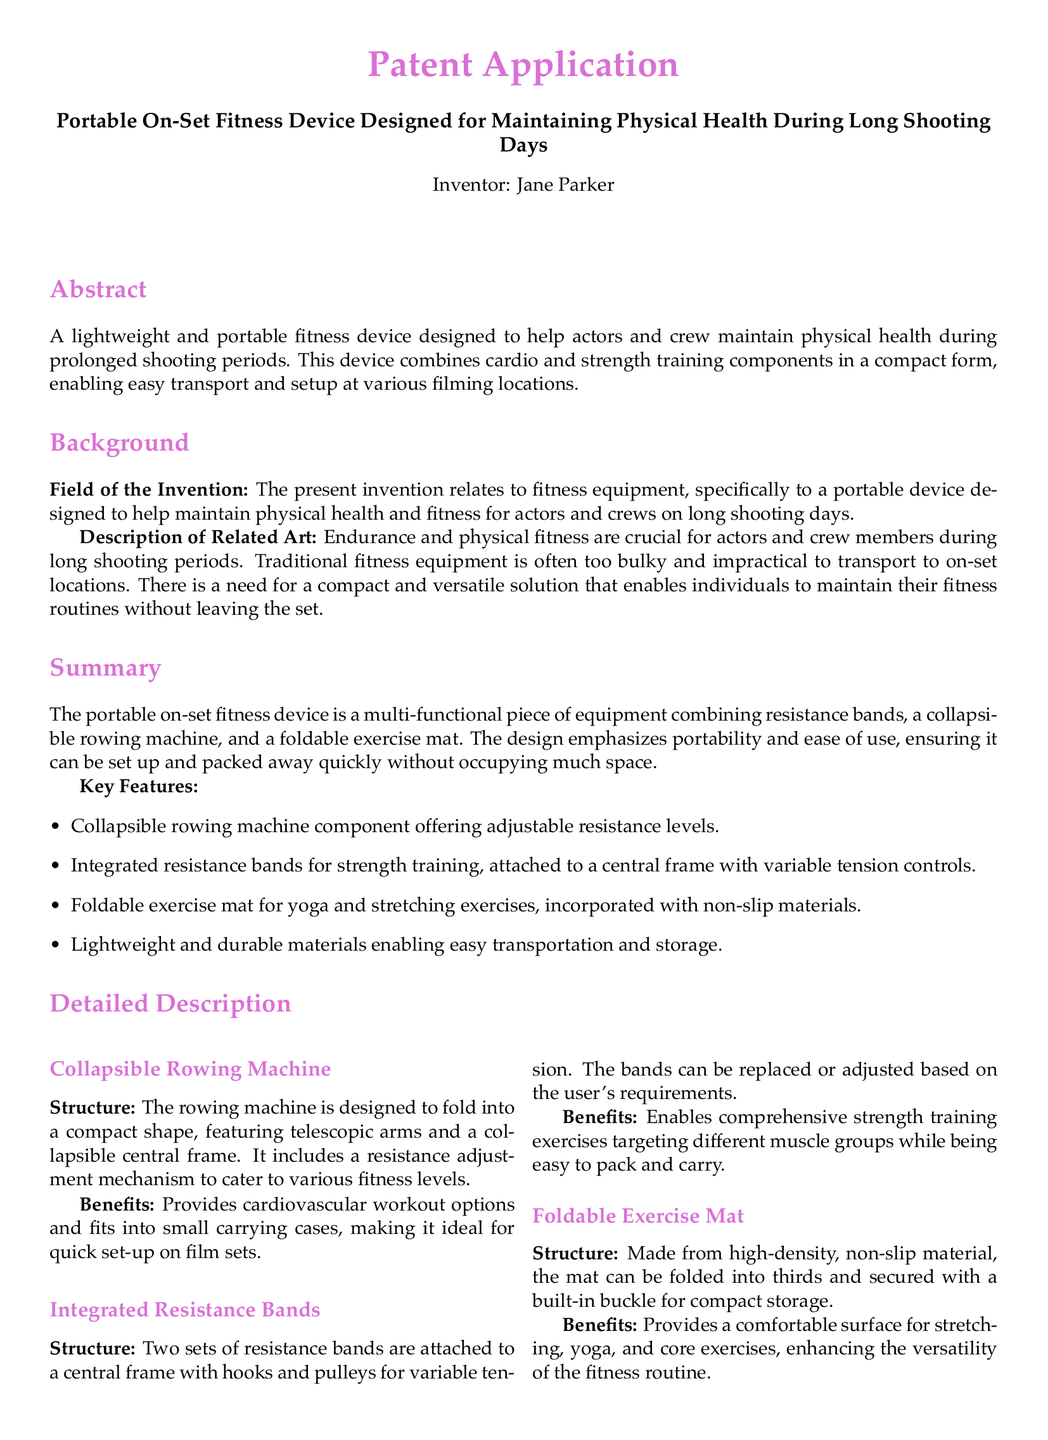What is the title of the patent application? The title of the patent application is indicated prominently at the top of the document.
Answer: Portable On-Set Fitness Device Designed for Maintaining Physical Health During Long Shooting Days Who is the inventor of the device? The inventor's name is mentioned in the document, providing credit to the creator.
Answer: Jane Parker What type of equipment does the invention relate to? The field of the invention is specified in the background section of the document.
Answer: Fitness equipment How many major components are described in the fitness device? The summary section lists the main components of the device.
Answer: Three What does the collapsible rowing machine provide? The benefits section mentions what the collapsible rowing machine offers.
Answer: Cardiovascular workout options What is the material of the foldable exercise mat? The detailed description of the exercise mat specifies its material.
Answer: High-density, non-slip material How many claims are included in the patent application? The claims section distinctly lists the claims made in the document.
Answer: Four What feature allows resistance bands to be customized? The detailed description of the integrated resistance bands mentions this feature.
Answer: Variable tension controls What facilitates easy transport and storage of the exercise mat? The detailed description highlights a particular feature of the exercise mat.
Answer: Built-in buckle 